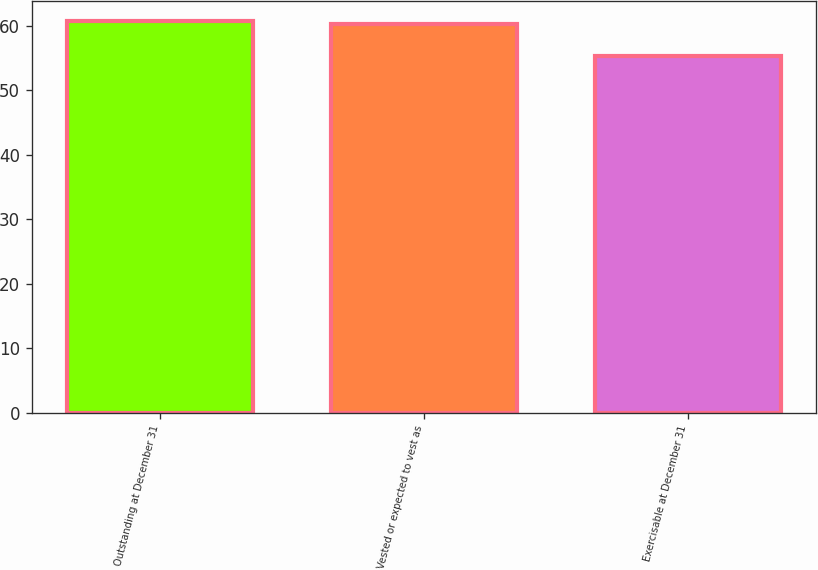Convert chart. <chart><loc_0><loc_0><loc_500><loc_500><bar_chart><fcel>Outstanding at December 31<fcel>Vested or expected to vest as<fcel>Exercisable at December 31<nl><fcel>60.76<fcel>60.25<fcel>55.36<nl></chart> 